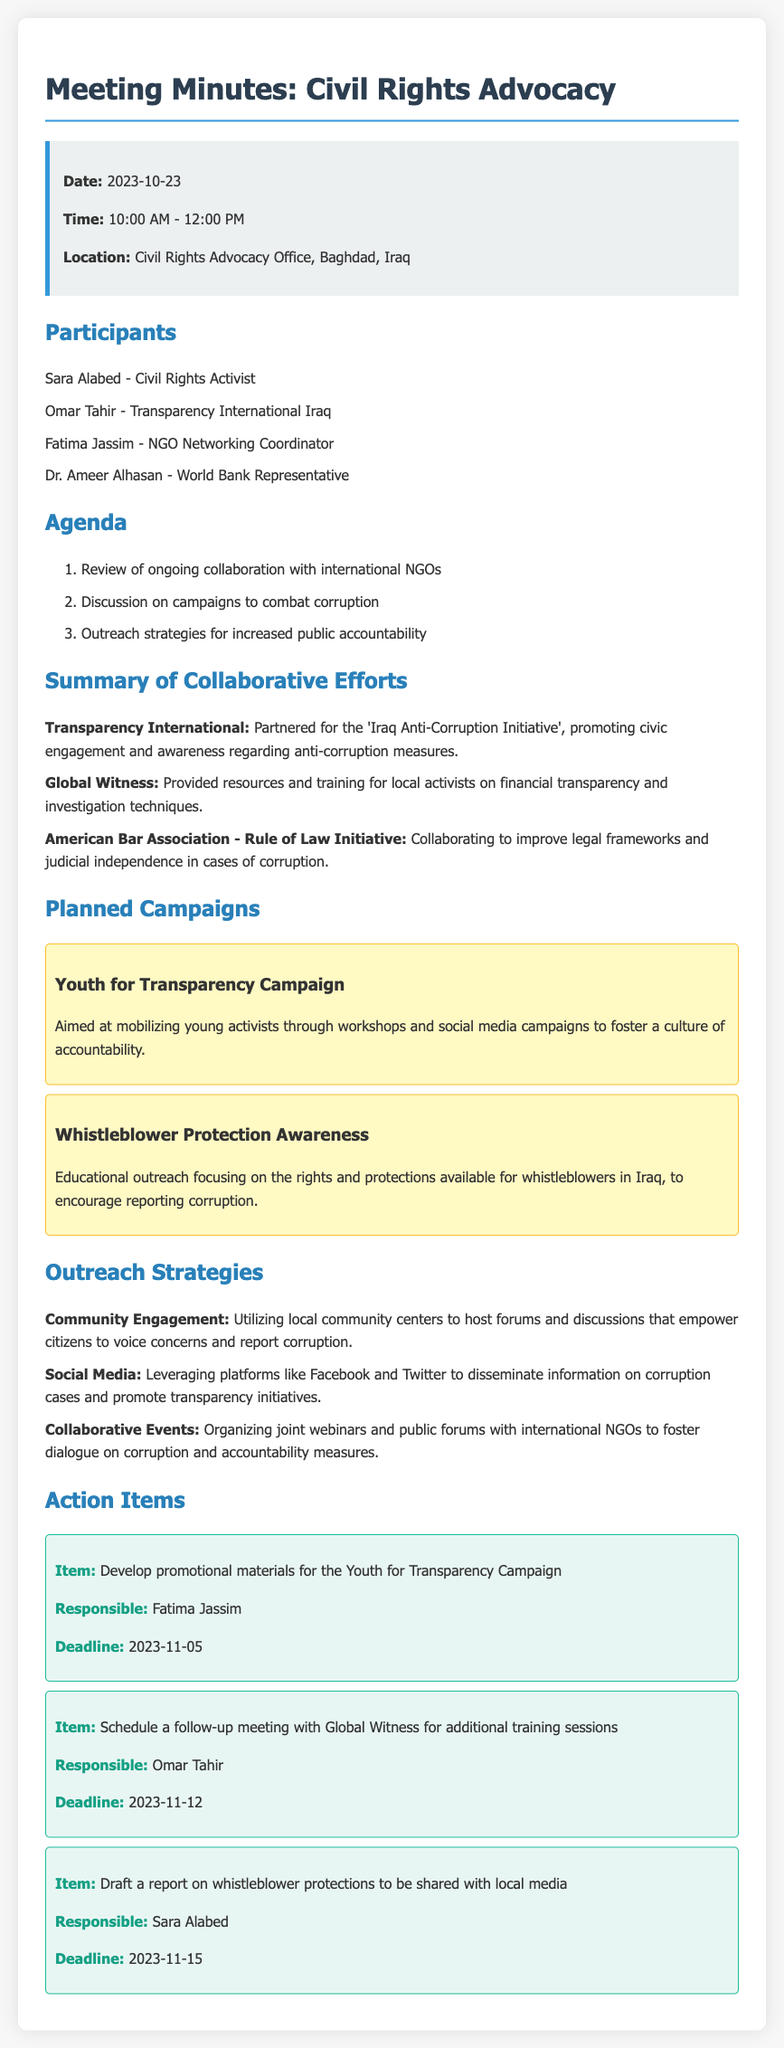What is the date of the meeting? The meeting date is specifically noted in the document under the info box section.
Answer: 2023-10-23 Who is responsible for developing promotional materials for the Youth for Transparency Campaign? This information is found in the action items section detailing responsibilities and tasks.
Answer: Fatima Jassim What is the focus of the Whistleblower Protection Awareness campaign? This is described under the planned campaigns, outlining the purpose of the educational outreach.
Answer: Educational outreach focusing on the rights and protections available for whistleblowers Which organization is collaborating to improve legal frameworks? The collaborative efforts specifically mention this organization in relation to improving legal frameworks.
Answer: American Bar Association - Rule of Law Initiative What is one of the outreach strategies mentioned in the document? The document states various outreach strategies, asking for examples, knowledge of which can be directly accessed from the relevant section.
Answer: Utilizing local community centers to host forums What time did the meeting start? The start time is explicitly stated in the document under the info box section.
Answer: 10:00 AM How many participants are listed in the meeting minutes? The number of participants is mentioned under the participants section, which lists all involved individuals.
Answer: Four What is one goal of the Iraq Anti-Corruption Initiative? This initiative is highlighted in the summary of collaborative efforts, detailing its objectives regarding civic engagement.
Answer: Promoting civic engagement and awareness regarding anti-corruption measures 